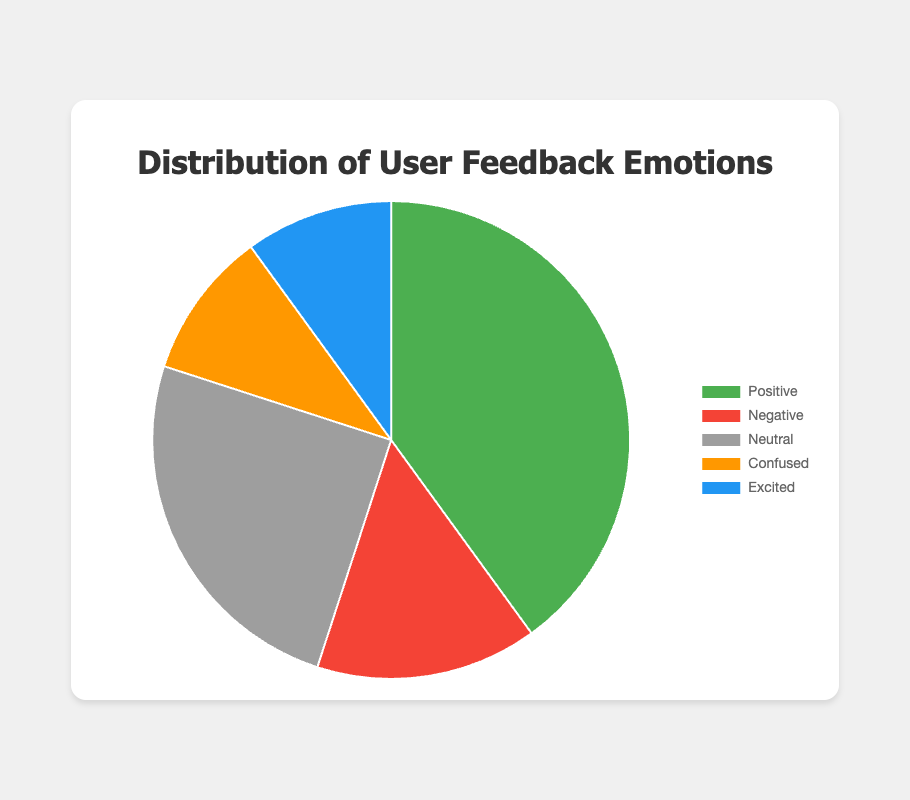Which emotion received the most feedback? The largest section of the pie chart represents the "Positive" feedback with 40%.
Answer: Positive Which two emotions have the same percentage of feedback? By looking at the pie chart, both "Confused" and "Excited" have 10% each.
Answer: Confused and Excited How much larger is the percentage of Positive feedback compared to Negative feedback? "Positive" feedback has 40% whereas "Negative" feedback has 15%. Subtract the two percentages: 40% - 15% = 25%.
Answer: 25% What is the total percentage of non-neutral (positive, negative, confused, excited) feedback? Sum the percentages of all emotions except "Neutral": 40% (Positive) + 15% (Negative) + 10% (Confused) + 10% (Excited) = 75%.
Answer: 75% What percentage of feedback is either Neutral or Confused? Add the percentages of "Neutral" and "Confused": 25% (Neutral) + 10% (Confused) = 35%.
Answer: 35% Which emotion's feedback is closest in percentage to Neutral feedback? "Neutral" feedback is 25%. The closest feedback is "Negative" with 15%, making the difference 10%, compared to 15% for the others.
Answer: Negative What is the ratio of Positive to Negative feedback? Positive feedback is 40% and Negative feedback is 15%. The ratio is 40:15 which simplifies to 8:3.
Answer: 8:3 Is there any category with a percentage less than 10%? No, the smallest percentages shown are "Confused" and "Excited" both at 10%.
Answer: No 